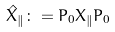<formula> <loc_0><loc_0><loc_500><loc_500>\hat { X } _ { \| } \colon = P _ { 0 } X _ { \| } P _ { 0 }</formula> 